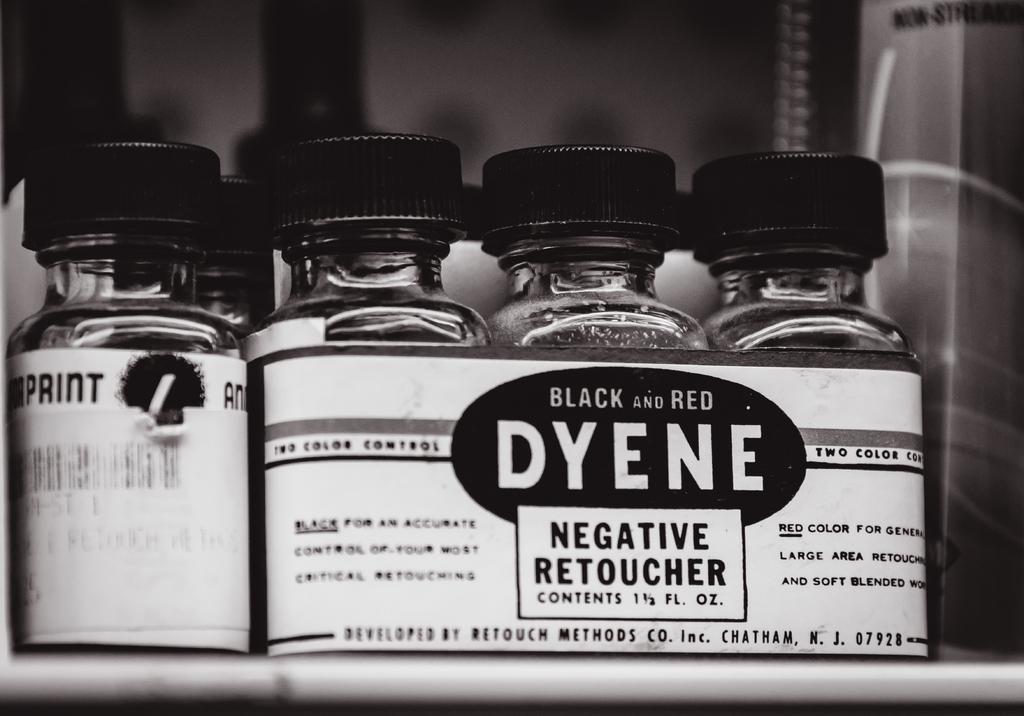Please provide a concise description of this image. In this image I can see many containers with caps. To the containers there is a paper attached. To the paper the name Dyene is written. 